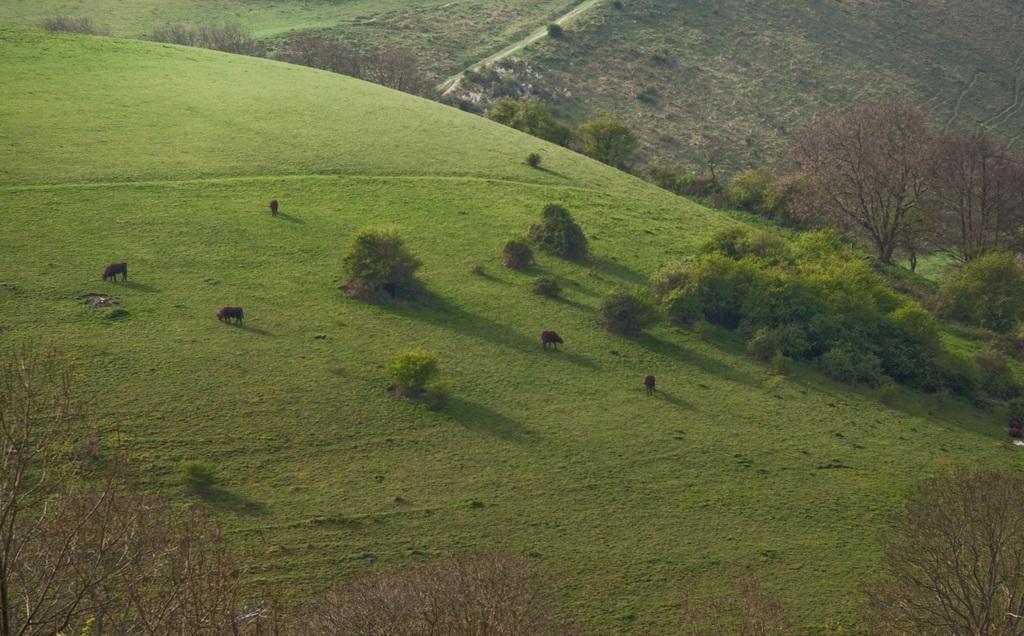Could you give a brief overview of what you see in this image? In center of the image there is grass. There are animals,trees. At the bottom of the image there are trees. In the background of the image there is a road. 